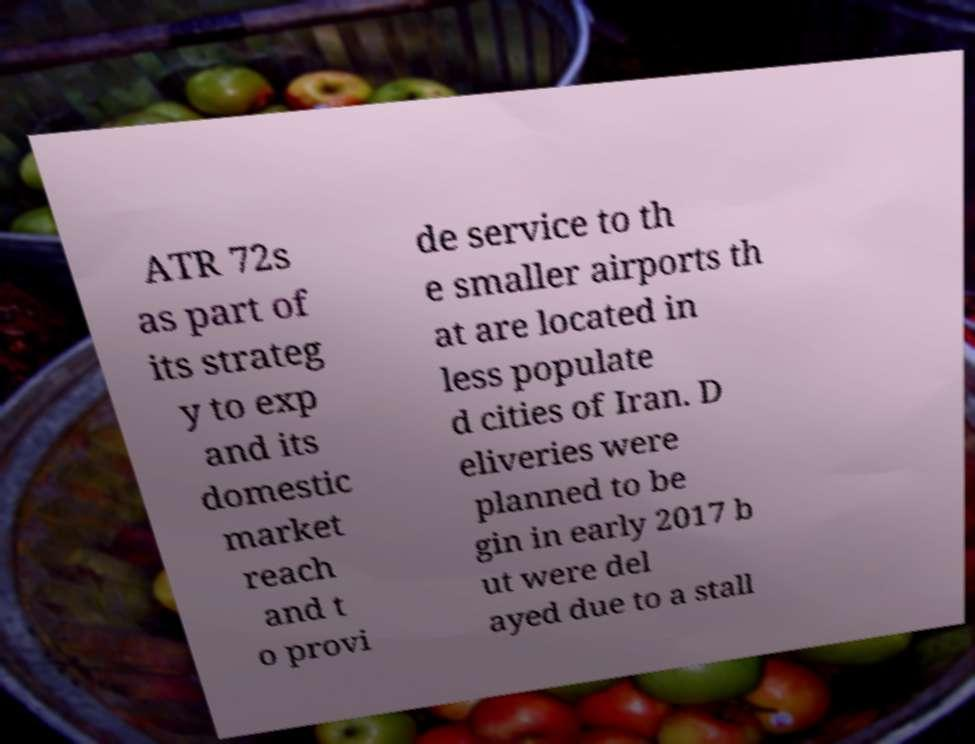For documentation purposes, I need the text within this image transcribed. Could you provide that? ATR 72s as part of its strateg y to exp and its domestic market reach and t o provi de service to th e smaller airports th at are located in less populate d cities of Iran. D eliveries were planned to be gin in early 2017 b ut were del ayed due to a stall 